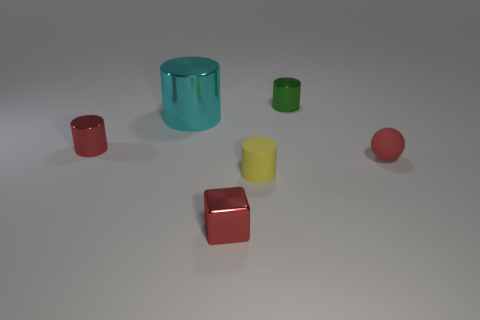Does the tiny yellow cylinder have the same material as the tiny red object behind the tiny matte ball?
Keep it short and to the point. No. The tiny red object on the right side of the small shiny cylinder to the right of the large cyan metallic cylinder is what shape?
Give a very brief answer. Sphere. There is a tiny object that is behind the tiny sphere and in front of the green cylinder; what is its shape?
Offer a very short reply. Cylinder. How many things are either small red rubber balls or small things that are behind the red shiny cylinder?
Your answer should be very brief. 2. What is the material of the red object that is the same shape as the small green thing?
Your answer should be very brief. Metal. Is there any other thing that has the same material as the tiny green thing?
Provide a succinct answer. Yes. There is a small cylinder that is on the right side of the big cylinder and in front of the cyan metallic object; what is it made of?
Your answer should be compact. Rubber. How many other things have the same shape as the big cyan shiny object?
Give a very brief answer. 3. There is a rubber object that is left of the rubber object that is to the right of the green cylinder; what is its color?
Offer a very short reply. Yellow. Are there the same number of green metallic cylinders in front of the yellow cylinder and gray metal things?
Ensure brevity in your answer.  Yes. 